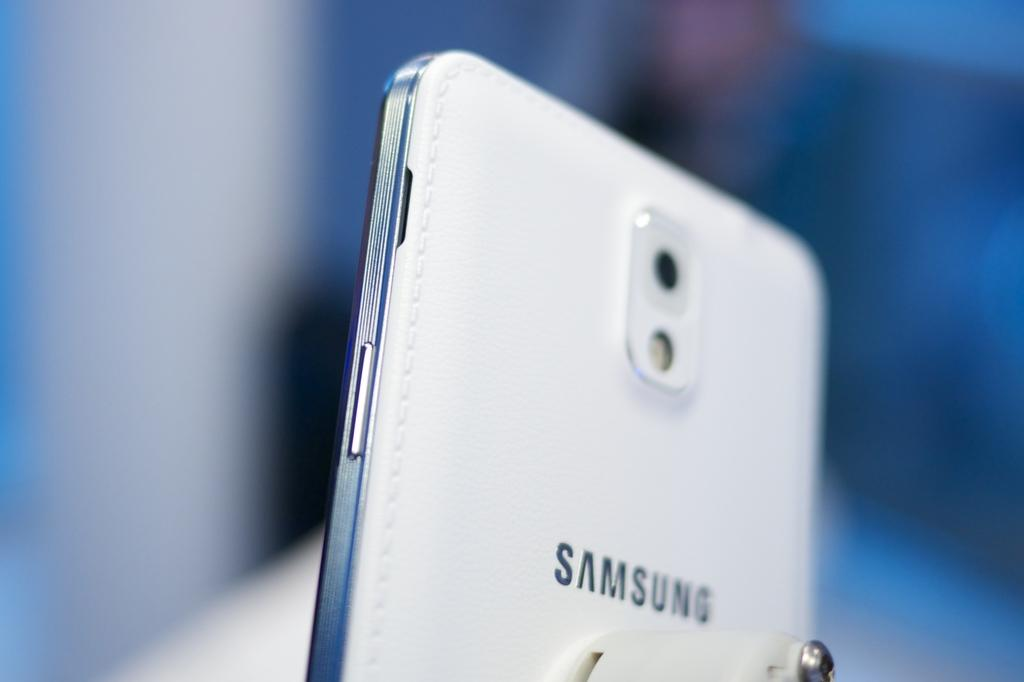<image>
Describe the image concisely. a samsing phone that is white and silver 